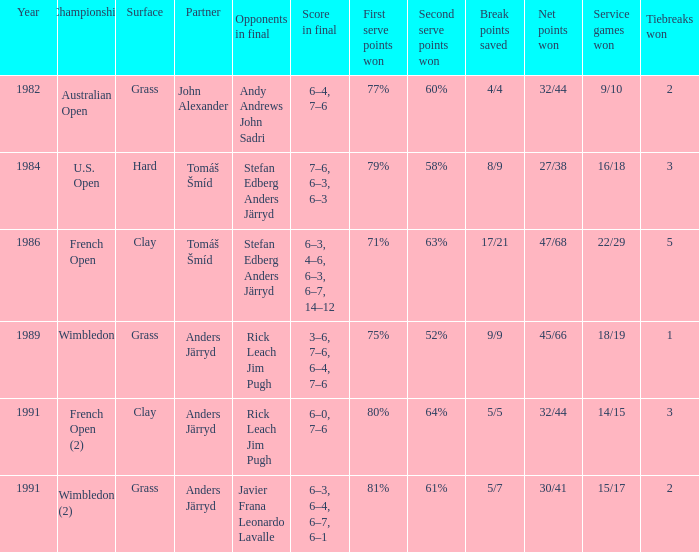What was the surface when he played with John Alexander?  Grass. 